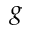<formula> <loc_0><loc_0><loc_500><loc_500>g</formula> 